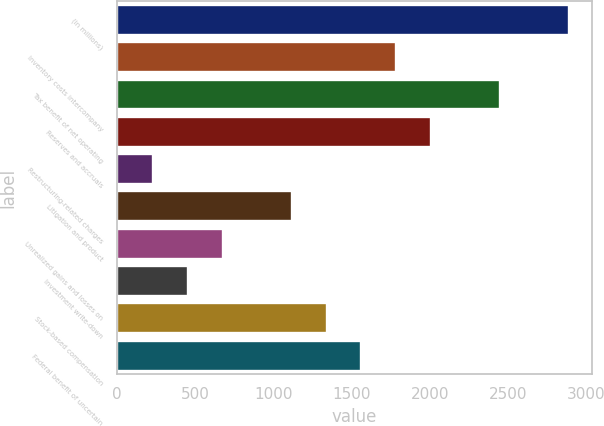Convert chart. <chart><loc_0><loc_0><loc_500><loc_500><bar_chart><fcel>(in millions)<fcel>Inventory costs intercompany<fcel>Tax benefit of net operating<fcel>Reserves and accruals<fcel>Restructuring-related charges<fcel>Litigation and product<fcel>Unrealized gains and losses on<fcel>Investment write-down<fcel>Stock-based compensation<fcel>Federal benefit of uncertain<nl><fcel>2891.8<fcel>1783.8<fcel>2448.6<fcel>2005.4<fcel>232.6<fcel>1119<fcel>675.8<fcel>454.2<fcel>1340.6<fcel>1562.2<nl></chart> 